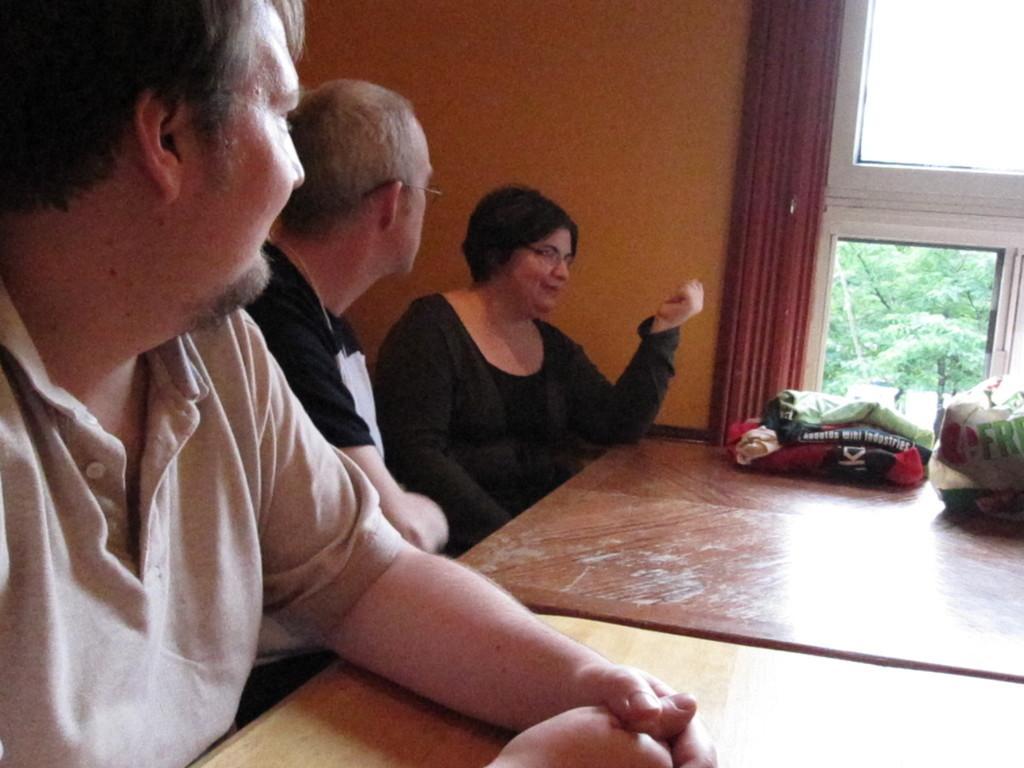In one or two sentences, can you explain what this image depicts? In this picture there are two men and one lady is sitting. To the left side there is a man with grey t-shirt is sitting. Beside him there is another man with black t-shirt is sitting. And the lady with black dress is sitting. In front of them there is a table. On the table there are clothes and plastic cover on it. And to the right top corner there is a window and an orange color wall. 